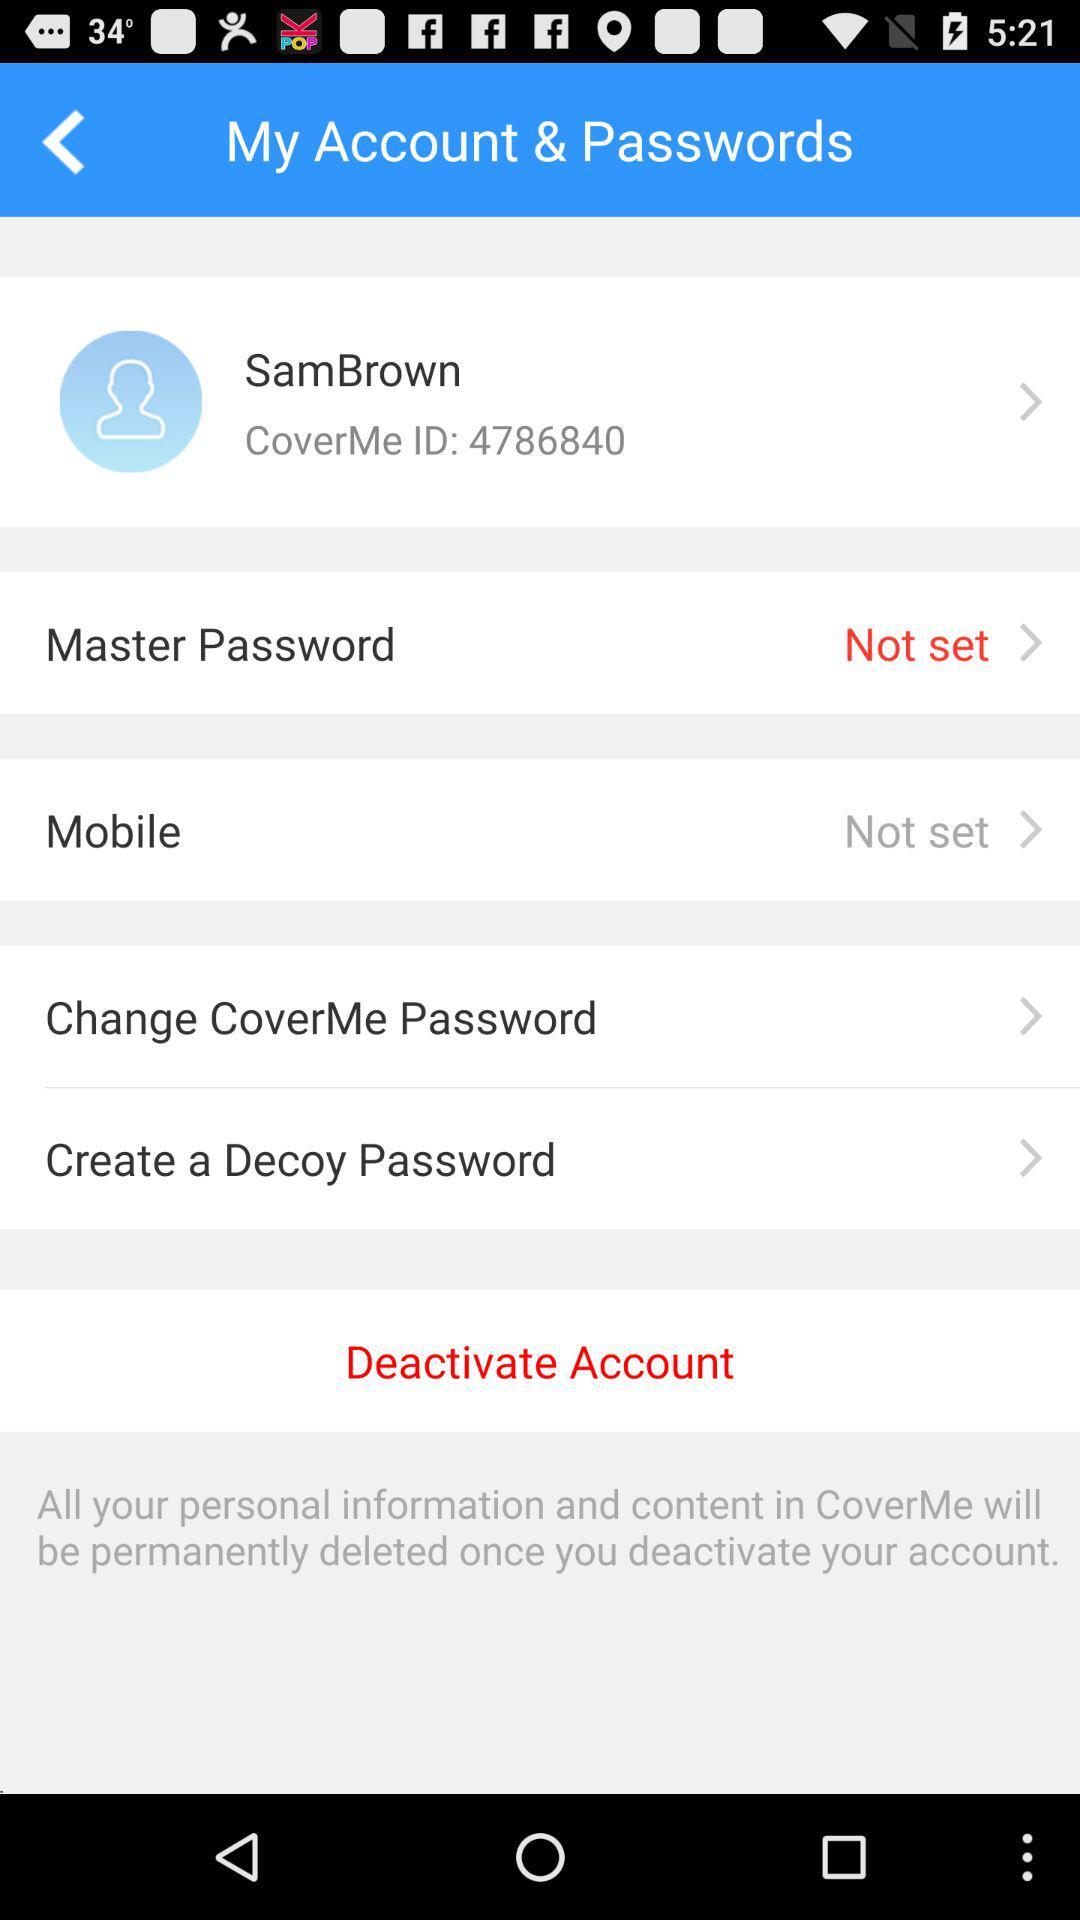What is the ID? The ID is 4786840. 